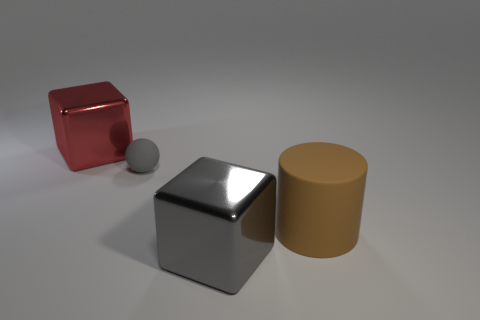Add 2 big yellow cubes. How many objects exist? 6 Subtract all yellow balls. Subtract all yellow cubes. How many balls are left? 1 Subtract all red spheres. How many red cubes are left? 1 Subtract all small gray matte balls. Subtract all big purple rubber spheres. How many objects are left? 3 Add 4 large gray metallic blocks. How many large gray metallic blocks are left? 5 Add 1 large gray cylinders. How many large gray cylinders exist? 1 Subtract 0 brown spheres. How many objects are left? 4 Subtract 1 cubes. How many cubes are left? 1 